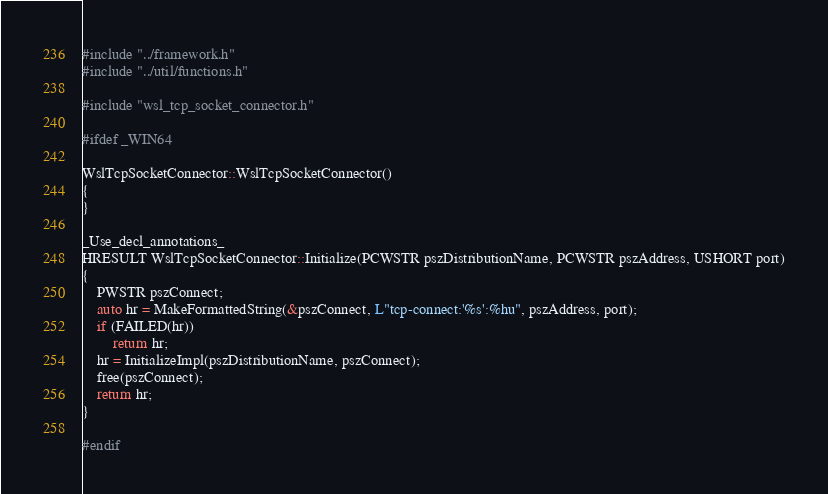Convert code to text. <code><loc_0><loc_0><loc_500><loc_500><_C++_>#include "../framework.h"
#include "../util/functions.h"

#include "wsl_tcp_socket_connector.h"

#ifdef _WIN64

WslTcpSocketConnector::WslTcpSocketConnector()
{
}

_Use_decl_annotations_
HRESULT WslTcpSocketConnector::Initialize(PCWSTR pszDistributionName, PCWSTR pszAddress, USHORT port)
{
    PWSTR pszConnect;
    auto hr = MakeFormattedString(&pszConnect, L"tcp-connect:'%s':%hu", pszAddress, port);
    if (FAILED(hr))
        return hr;
    hr = InitializeImpl(pszDistributionName, pszConnect);
    free(pszConnect);
    return hr;
}

#endif
</code> 